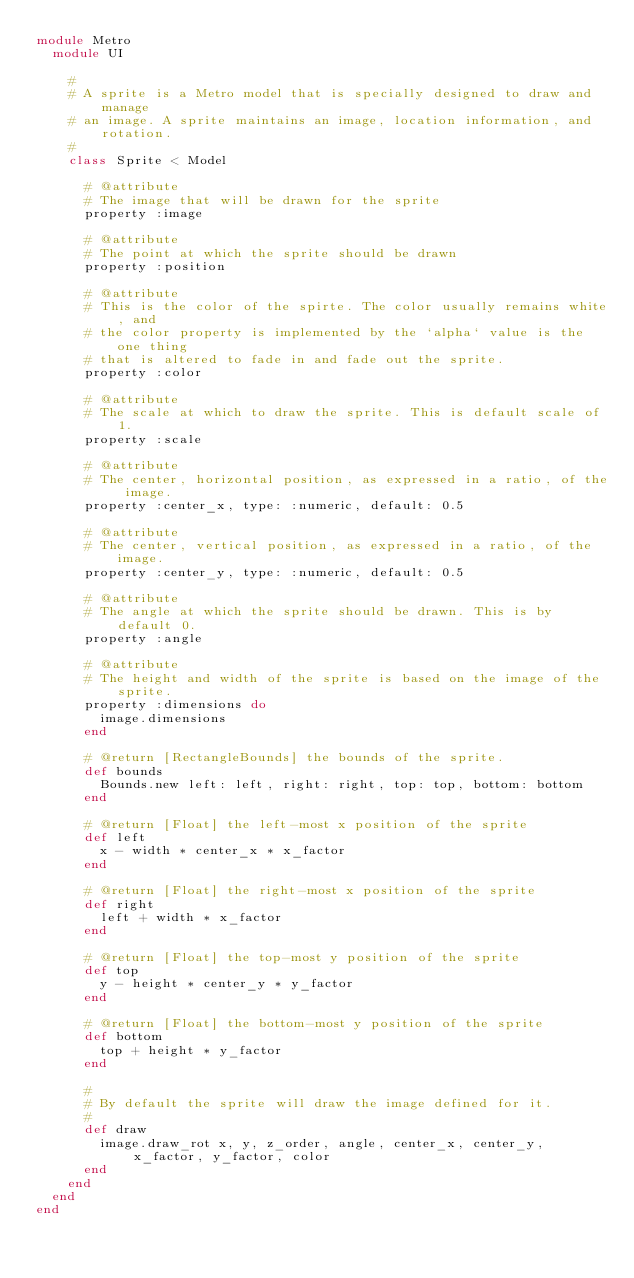Convert code to text. <code><loc_0><loc_0><loc_500><loc_500><_Ruby_>module Metro
  module UI

    #
    # A sprite is a Metro model that is specially designed to draw and manage
    # an image. A sprite maintains an image, location information, and rotation.
    #
    class Sprite < Model

      # @attribute
      # The image that will be drawn for the sprite
      property :image

      # @attribute
      # The point at which the sprite should be drawn
      property :position

      # @attribute
      # This is the color of the spirte. The color usually remains white, and
      # the color property is implemented by the `alpha` value is the one thing
      # that is altered to fade in and fade out the sprite.
      property :color

      # @attribute
      # The scale at which to draw the sprite. This is default scale of 1.
      property :scale

      # @attribute
      # The center, horizontal position, as expressed in a ratio, of the image.
      property :center_x, type: :numeric, default: 0.5

      # @attribute
      # The center, vertical position, as expressed in a ratio, of the image.
      property :center_y, type: :numeric, default: 0.5

      # @attribute
      # The angle at which the sprite should be drawn. This is by default 0.
      property :angle

      # @attribute
      # The height and width of the sprite is based on the image of the sprite.
      property :dimensions do
        image.dimensions
      end

      # @return [RectangleBounds] the bounds of the sprite.
      def bounds
        Bounds.new left: left, right: right, top: top, bottom: bottom
      end

      # @return [Float] the left-most x position of the sprite
      def left
        x - width * center_x * x_factor
      end

      # @return [Float] the right-most x position of the sprite
      def right
        left + width * x_factor
      end

      # @return [Float] the top-most y position of the sprite
      def top
        y - height * center_y * y_factor
      end

      # @return [Float] the bottom-most y position of the sprite
      def bottom
        top + height * y_factor
      end

      #
      # By default the sprite will draw the image defined for it.
      #
      def draw
        image.draw_rot x, y, z_order, angle, center_x, center_y, x_factor, y_factor, color
      end
    end
  end
end</code> 